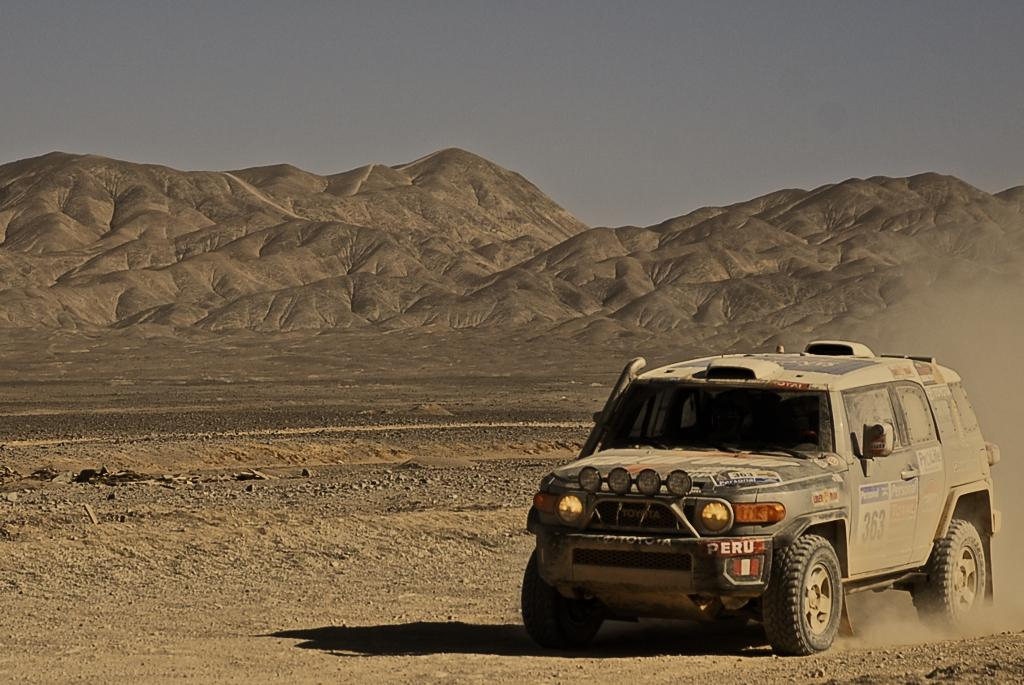What is the main subject of the image? There is a vehicle in the image. What else can be seen in the image besides the vehicle? There is a shadow and the sky is visible in the image. Are there any markings or text on the vehicle? Yes, there is writing on the vehicle at a few places. What type of rhythm can be heard coming from the vehicle in the image? There is no sound or rhythm associated with the vehicle in the image. Can you see any needles or blood in the image? No, there are no needles or blood present in the image. 